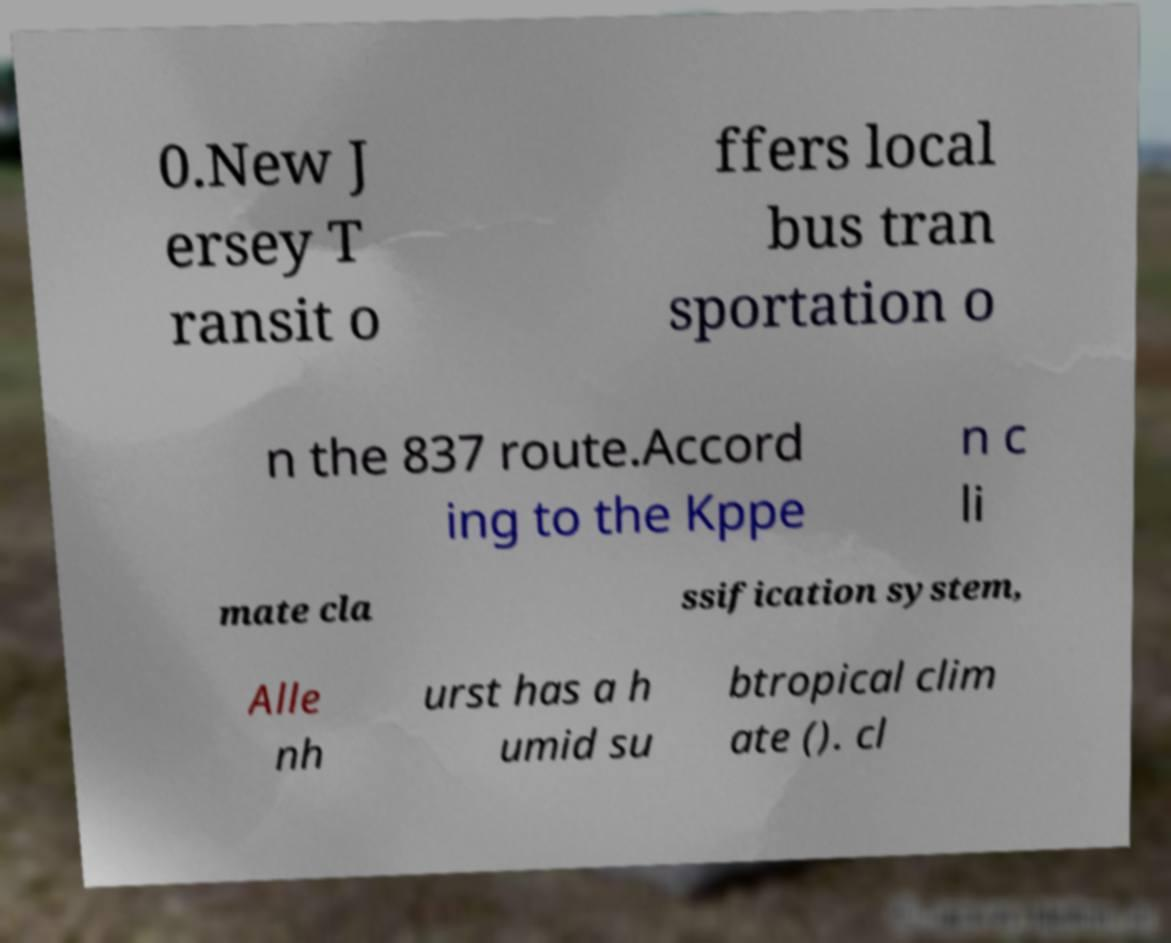Could you assist in decoding the text presented in this image and type it out clearly? 0.New J ersey T ransit o ffers local bus tran sportation o n the 837 route.Accord ing to the Kppe n c li mate cla ssification system, Alle nh urst has a h umid su btropical clim ate (). cl 